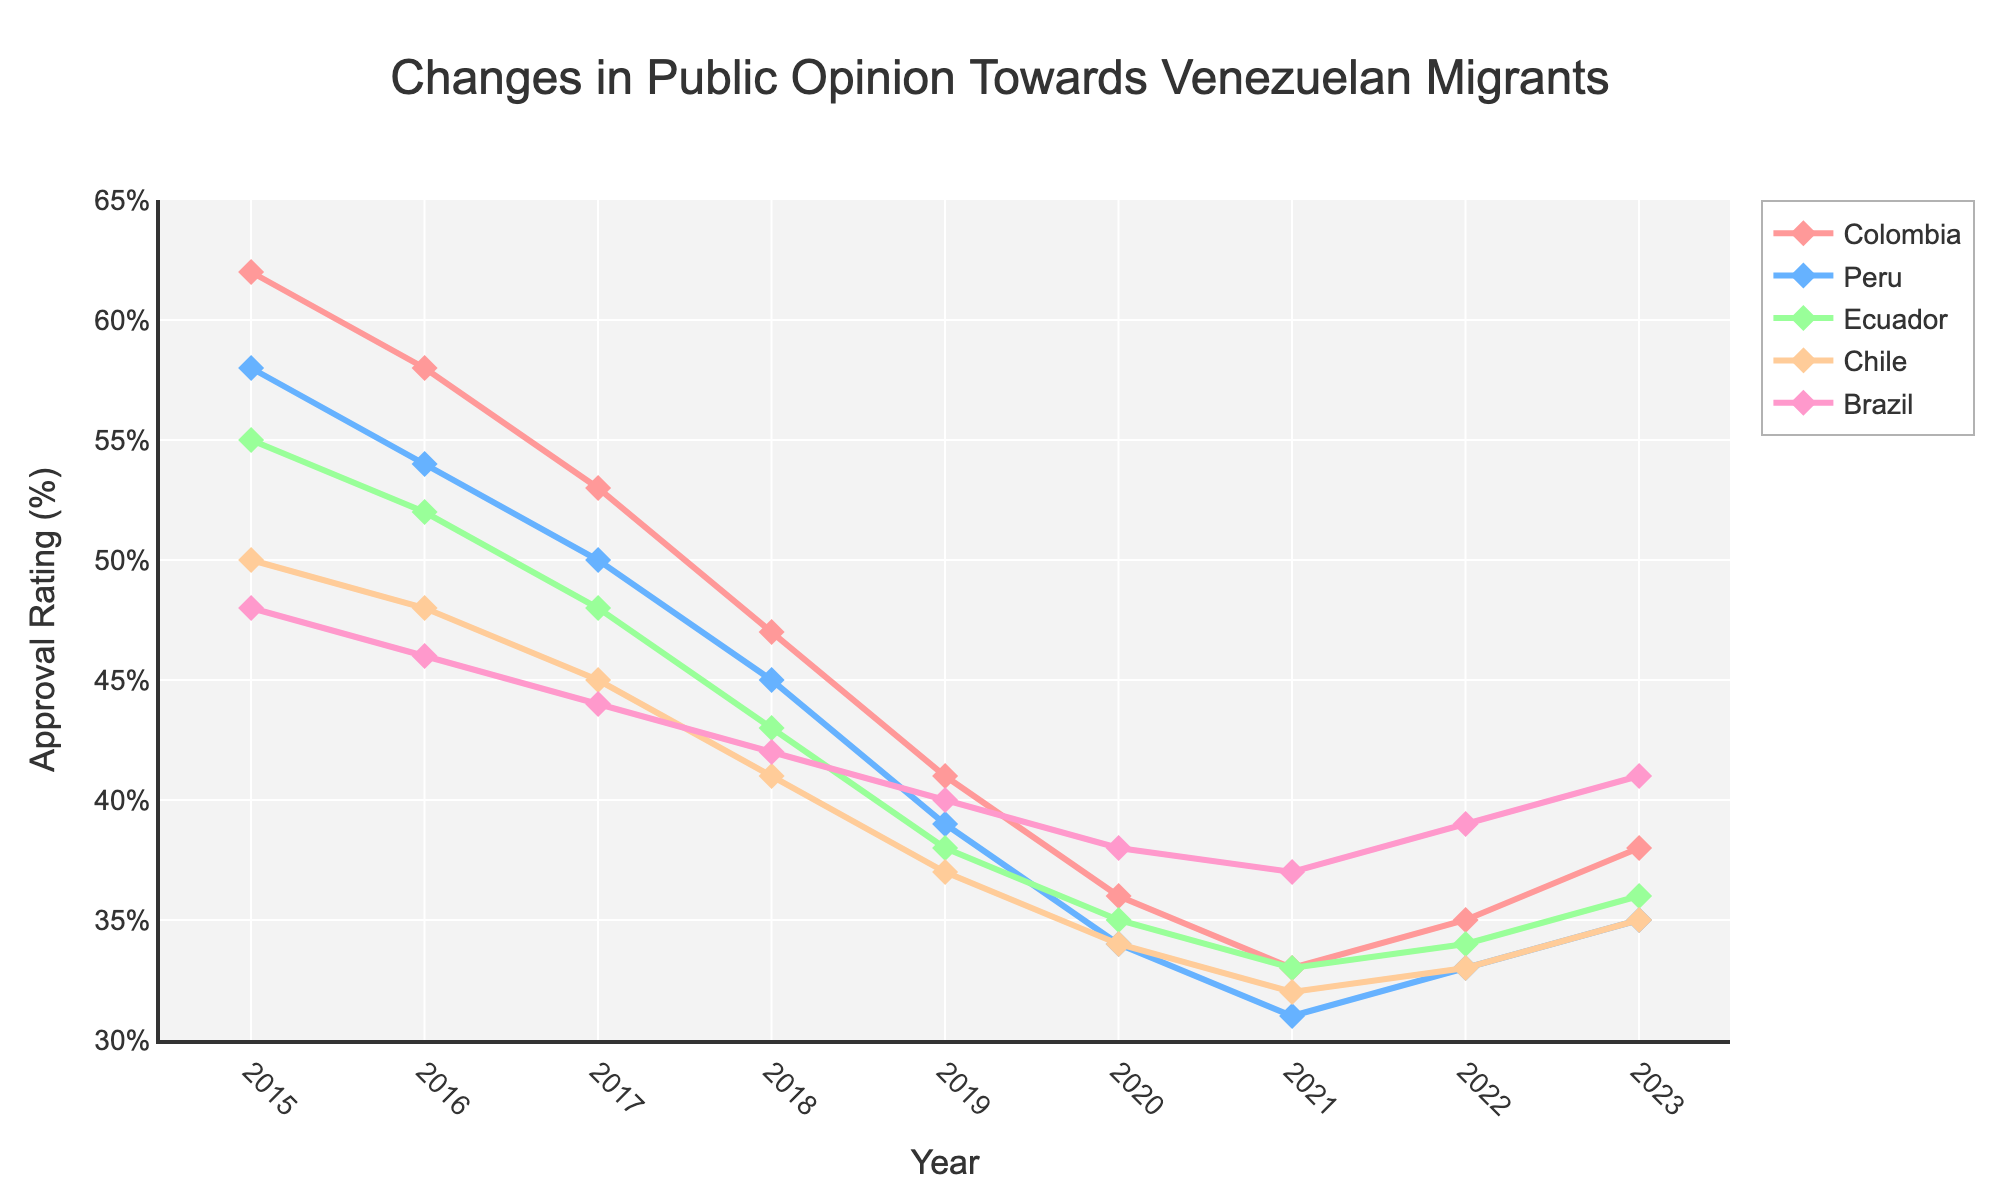Which country had the highest approval rating for Venezuelan migrants in 2015? Look at the approval ratings for each country in 2015. The highest value is 62 for Colombia.
Answer: Colombia What was the trend in approval ratings in Brazil from 2015 to 2023? Observe the approval ratings for Brazil over the years. The values are 48 (2015), 46 (2016), 44 (2017), 42 (2018), 40 (2019), 38 (2020), 37 (2021), 39 (2022), and 41 (2023). The general trend is a decline until 2021, followed by a slight increase.
Answer: Decline until 2021, then slight increase In which year did Ecuador have the lowest approval rating, and what was the rating? Check the approval ratings for Ecuador over the years. The lowest value is 33 in 2021.
Answer: 2021, 33 Compare the approval ratings of Peru and Chile in 2018. Which country had a higher rating? Look at the approval ratings for Peru and Chile in 2018. Peru had a rating of 45 and Chile had a rating of 41. Thus, Peru had the higher rating.
Answer: Peru Which country showed an increase in approval rating from 2021 to 2023? Check the approval ratings from 2021 to 2023 for each country. Colombia (33 to 38), Peru (31 to 35), Ecuador (33 to 36), Chile (32 to 35), and Brazil (37 to 41) all show an increase.
Answer: All countries What is the difference in approval rating for Colombia between 2015 and 2020? Subtract the approval rating for Colombia in 2020 from that in 2015. It is 62 (2015) - 36 (2020) = 26.
Answer: 26 What are the average approval ratings for Chile and Brazil in 2017? Sum the approval ratings for Chile and Brazil in 2017 and divide by 2. It is (45 + 44) / 2 = 44.5.
Answer: 44.5 How did the approval rating for Peru change from 2019 to 2022? Check the approval ratings for Peru from 2019 to 2022. The values are 39 (2019), 34 (2020), 31 (2021), and 33 (2022). The approval rating decreased from 39 to 31, then increased to 33.
Answer: Decreased then increased Which country’s approval ratings remained the most stable between 2015 and 2023? Evaluate the changes in approval ratings for each country over the period. Brazil has the smallest overall change (48 to 41).
Answer: Brazil What was the combined approval rating of Peru and Ecuador in 2020? Add the approval ratings for Peru and Ecuador in 2020. It is 34 (Peru) + 35 (Ecuador) = 69.
Answer: 69 